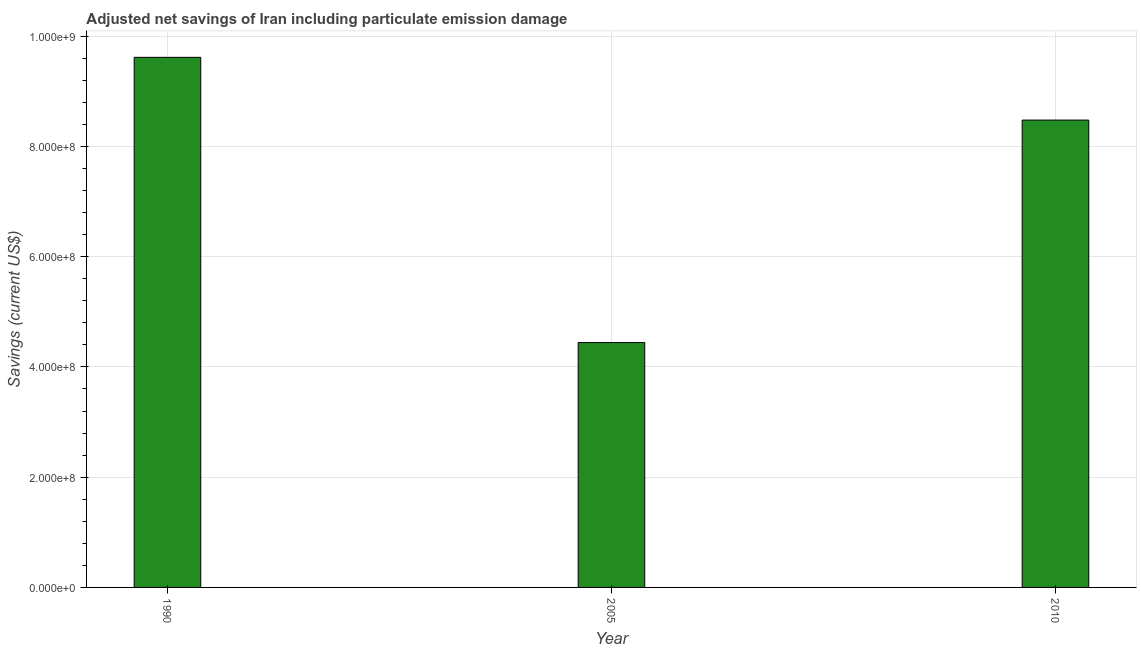Does the graph contain grids?
Make the answer very short. Yes. What is the title of the graph?
Give a very brief answer. Adjusted net savings of Iran including particulate emission damage. What is the label or title of the X-axis?
Provide a succinct answer. Year. What is the label or title of the Y-axis?
Keep it short and to the point. Savings (current US$). What is the adjusted net savings in 1990?
Keep it short and to the point. 9.62e+08. Across all years, what is the maximum adjusted net savings?
Offer a very short reply. 9.62e+08. Across all years, what is the minimum adjusted net savings?
Give a very brief answer. 4.44e+08. In which year was the adjusted net savings maximum?
Keep it short and to the point. 1990. In which year was the adjusted net savings minimum?
Your response must be concise. 2005. What is the sum of the adjusted net savings?
Give a very brief answer. 2.25e+09. What is the difference between the adjusted net savings in 1990 and 2010?
Provide a succinct answer. 1.14e+08. What is the average adjusted net savings per year?
Offer a terse response. 7.51e+08. What is the median adjusted net savings?
Give a very brief answer. 8.48e+08. What is the ratio of the adjusted net savings in 1990 to that in 2005?
Offer a terse response. 2.17. What is the difference between the highest and the second highest adjusted net savings?
Your answer should be compact. 1.14e+08. What is the difference between the highest and the lowest adjusted net savings?
Give a very brief answer. 5.17e+08. In how many years, is the adjusted net savings greater than the average adjusted net savings taken over all years?
Your answer should be compact. 2. How many years are there in the graph?
Provide a short and direct response. 3. What is the difference between two consecutive major ticks on the Y-axis?
Your answer should be very brief. 2.00e+08. What is the Savings (current US$) of 1990?
Make the answer very short. 9.62e+08. What is the Savings (current US$) of 2005?
Offer a terse response. 4.44e+08. What is the Savings (current US$) in 2010?
Your response must be concise. 8.48e+08. What is the difference between the Savings (current US$) in 1990 and 2005?
Ensure brevity in your answer.  5.17e+08. What is the difference between the Savings (current US$) in 1990 and 2010?
Provide a short and direct response. 1.14e+08. What is the difference between the Savings (current US$) in 2005 and 2010?
Your response must be concise. -4.04e+08. What is the ratio of the Savings (current US$) in 1990 to that in 2005?
Your answer should be very brief. 2.17. What is the ratio of the Savings (current US$) in 1990 to that in 2010?
Give a very brief answer. 1.13. What is the ratio of the Savings (current US$) in 2005 to that in 2010?
Make the answer very short. 0.52. 